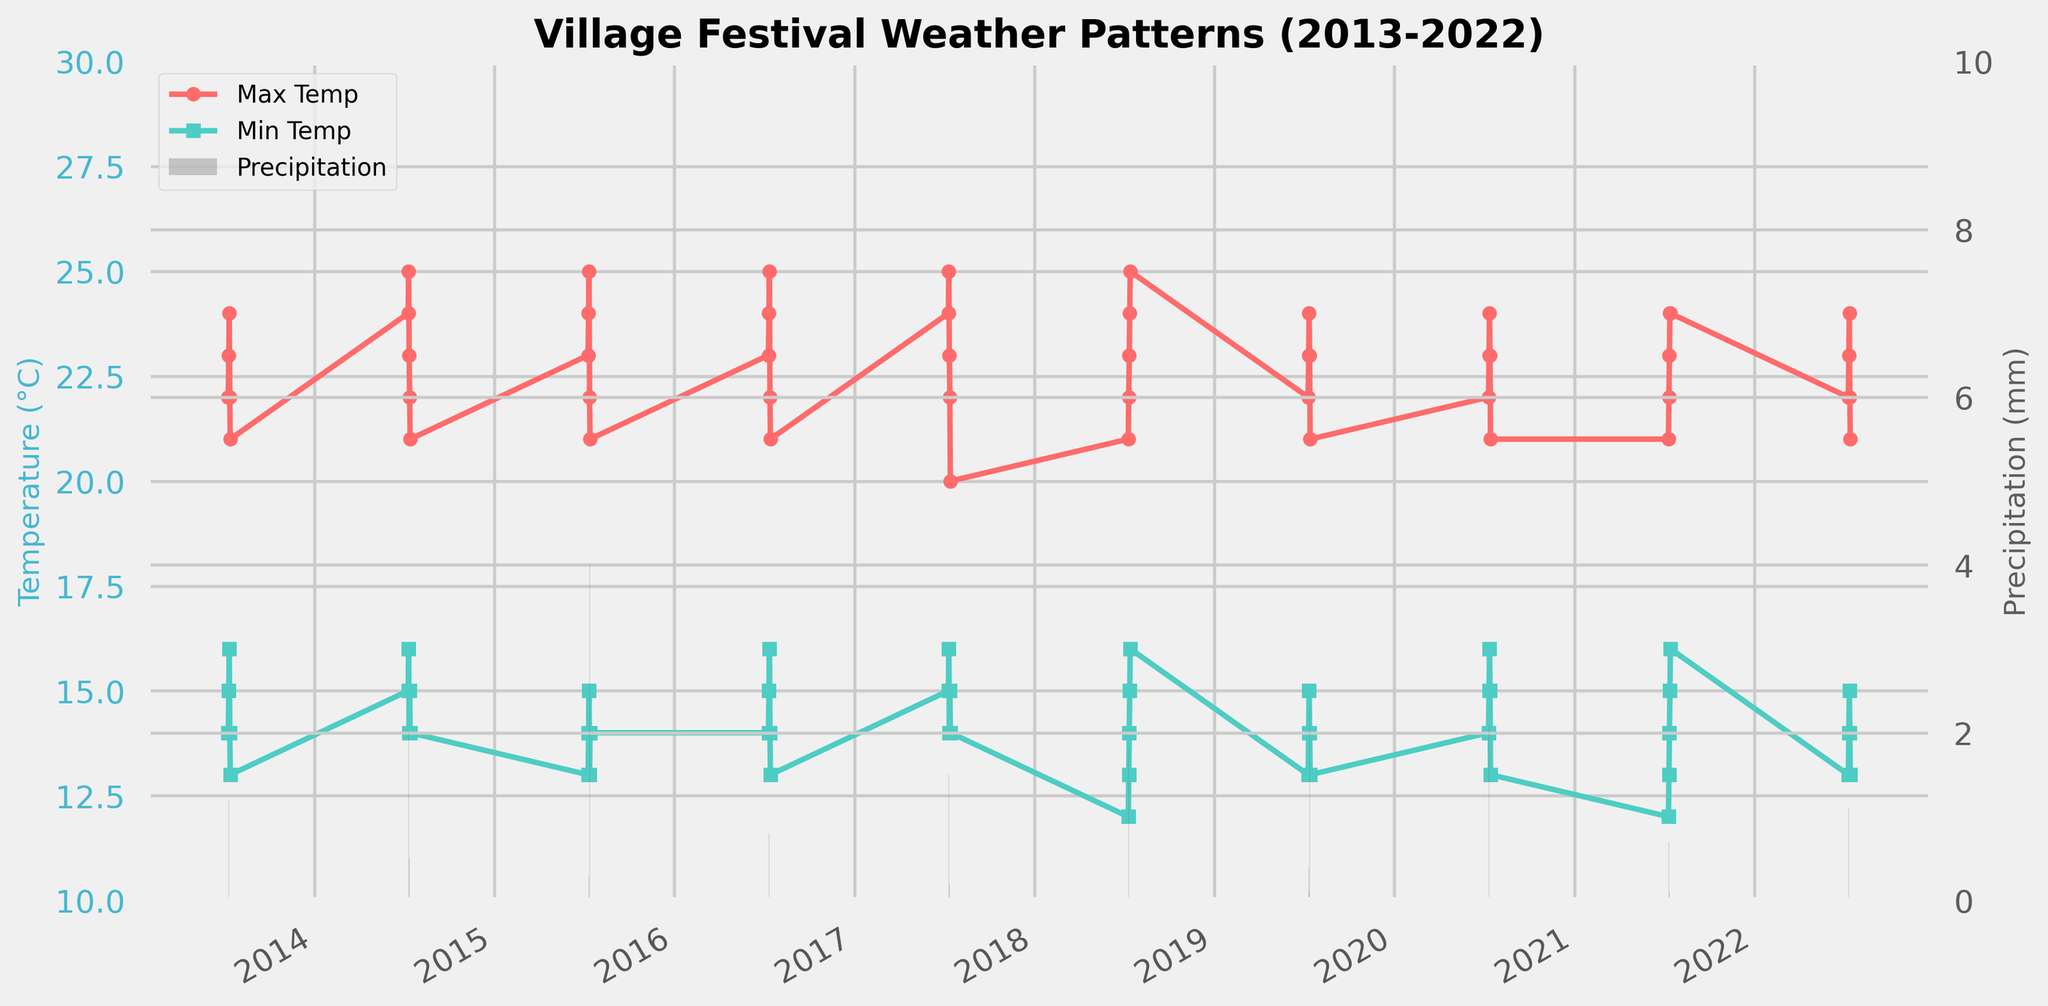What's the title of the figure? The title is usually located at the top of the figure and summarizes the content or subject of the plot.
Answer: Village Festival Weather Patterns (2013-2022) What are the two types of data represented in the figure? The figure shows two types of data: temperatures (Max Temp and Min Temp as lines) and precipitation (as bars). This can be seen by observing the lines and bars on the plot, as well as the labels on the y-axes.
Answer: Temperature and precipitation What is the color of the Max Temp line? The Max Temp line can be identified by its color, which is explicitly shown in the plot legend.
Answer: Red Which year experienced the highest maximum temperature? The figure shows the Max Temp values over the years. By looking at the highest point in the Max Temp line across the x-axis (years), you can determine the year with the highest maximum temperature.
Answer: 2018 What is the average minimum temperature between 2013 and 2022? To find the average minimum temperature, note down all the points (values) of the Min_Temperature_C line and calculate their mean. In this plot, each year has one Min Temp for July 10-14, you sum them up and divide by the number of years. E.g., (14 + 15 + 16 + 14 + 13 + 15 + 16 + 14 + 12 + 14 + 13) / 10 = 14.2
Answer: 14.2°C In which year did July 11 have the highest precipitation? Collect the precipitation data for July 11 across all years and identify the highest value from the bar height. The corresponding year will show the shaded bar at its highest.
Answer: 2020 Compare the range of temperatures in 2015 and 2020. Which had a greater range? Calculate the temperature range for each year by subtracting the minimum temperature from the maximum temperature for each respective year and compare the two values. For instance, for 2015: max-min = 25-13 = 12°C. For 2020: max-min = 24-14 = 10°C. Then compare the results.
Answer: 2015 On average, which day of the festival had the highest max temperature over the 10 years? Analyze the Max Temp values for each day (July 10-14) over the 10 years and calculate the average for each day. The day with the highest average maximum temperature is the answer. E.g., averaging the temperatures for one of the days and comparing all.
Answer: July 12 How does the rainfall pattern change over the festival days for the year 2017? To detect the rainfall pattern, observe the bar heights corresponding to the festival days in 2017 and compare them to see if there is an increasing, decreasing, or fluctuating pattern.
Answer: Fluctuates Which year had the highest average humidity? Although not immediately visible from the plot provided, if assuming similar data patterns (if there were humidity plotted), you'd typically compare the average humidity values from another view of dataset or legend on the plot.
Answer: Not provided in the plot 